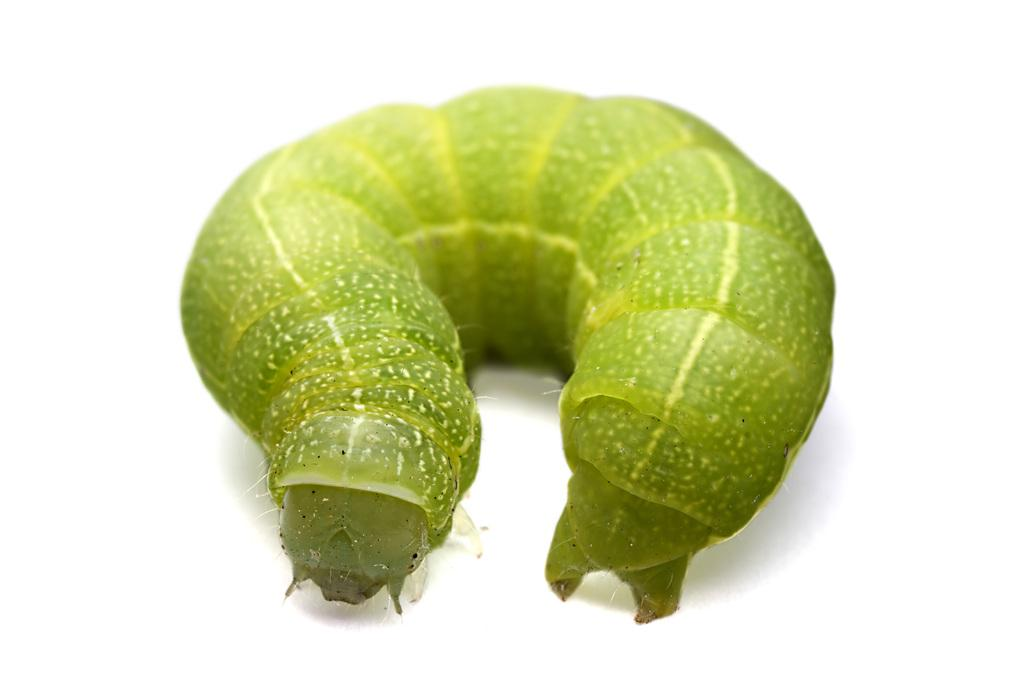What is the main subject of the image? The main subject of the image is a caterpillar. What color is the background of the image? The background of the image is white. How many cards are being smashed by the kittens in the image? There are no cards or kittens present in the image; it features a caterpillar against a white background. 